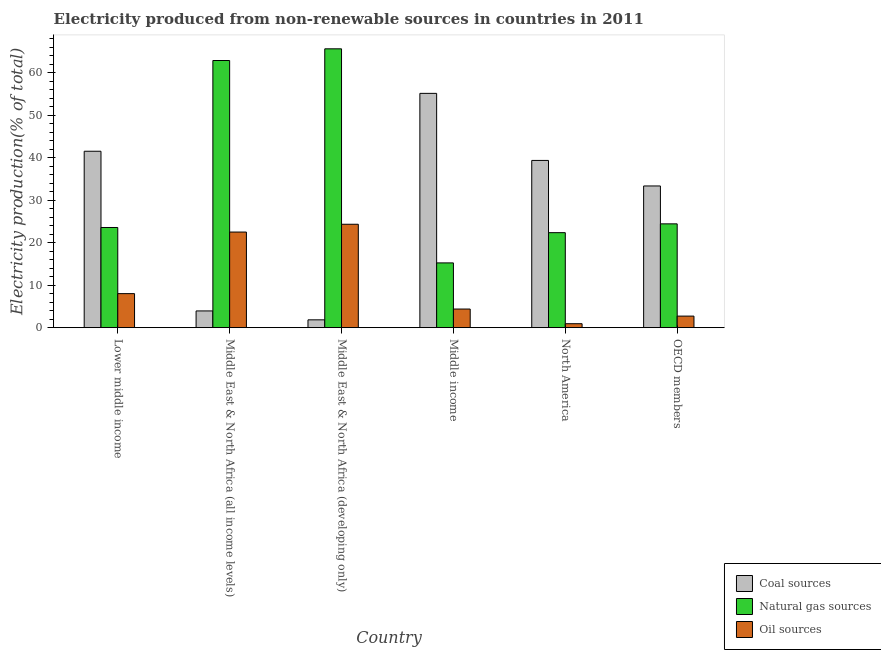What is the percentage of electricity produced by coal in Middle income?
Your answer should be very brief. 55.1. Across all countries, what is the maximum percentage of electricity produced by coal?
Your answer should be compact. 55.1. Across all countries, what is the minimum percentage of electricity produced by oil sources?
Ensure brevity in your answer.  0.93. In which country was the percentage of electricity produced by oil sources maximum?
Your answer should be compact. Middle East & North Africa (developing only). What is the total percentage of electricity produced by coal in the graph?
Ensure brevity in your answer.  175.02. What is the difference between the percentage of electricity produced by coal in Middle East & North Africa (developing only) and that in North America?
Your answer should be compact. -37.49. What is the difference between the percentage of electricity produced by natural gas in OECD members and the percentage of electricity produced by oil sources in Middle East & North Africa (all income levels)?
Your answer should be very brief. 1.93. What is the average percentage of electricity produced by natural gas per country?
Provide a short and direct response. 35.66. What is the difference between the percentage of electricity produced by oil sources and percentage of electricity produced by coal in Middle income?
Your answer should be compact. -50.72. In how many countries, is the percentage of electricity produced by oil sources greater than 60 %?
Your response must be concise. 0. What is the ratio of the percentage of electricity produced by coal in Middle East & North Africa (all income levels) to that in North America?
Your answer should be compact. 0.1. Is the percentage of electricity produced by oil sources in Lower middle income less than that in Middle East & North Africa (developing only)?
Ensure brevity in your answer.  Yes. Is the difference between the percentage of electricity produced by coal in Lower middle income and Middle income greater than the difference between the percentage of electricity produced by oil sources in Lower middle income and Middle income?
Your answer should be very brief. No. What is the difference between the highest and the second highest percentage of electricity produced by coal?
Your answer should be very brief. 13.61. What is the difference between the highest and the lowest percentage of electricity produced by natural gas?
Offer a very short reply. 50.35. In how many countries, is the percentage of electricity produced by oil sources greater than the average percentage of electricity produced by oil sources taken over all countries?
Your answer should be compact. 2. What does the 3rd bar from the left in Middle East & North Africa (all income levels) represents?
Offer a terse response. Oil sources. What does the 2nd bar from the right in North America represents?
Give a very brief answer. Natural gas sources. Is it the case that in every country, the sum of the percentage of electricity produced by coal and percentage of electricity produced by natural gas is greater than the percentage of electricity produced by oil sources?
Provide a succinct answer. Yes. How many bars are there?
Your response must be concise. 18. Are the values on the major ticks of Y-axis written in scientific E-notation?
Ensure brevity in your answer.  No. Does the graph contain grids?
Provide a succinct answer. No. How are the legend labels stacked?
Your answer should be very brief. Vertical. What is the title of the graph?
Provide a succinct answer. Electricity produced from non-renewable sources in countries in 2011. Does "Textiles and clothing" appear as one of the legend labels in the graph?
Provide a short and direct response. No. What is the label or title of the X-axis?
Ensure brevity in your answer.  Country. What is the Electricity production(% of total) in Coal sources in Lower middle income?
Provide a succinct answer. 41.49. What is the Electricity production(% of total) in Natural gas sources in Lower middle income?
Provide a succinct answer. 23.56. What is the Electricity production(% of total) in Oil sources in Lower middle income?
Provide a succinct answer. 8. What is the Electricity production(% of total) in Coal sources in Middle East & North Africa (all income levels)?
Your answer should be compact. 3.93. What is the Electricity production(% of total) in Natural gas sources in Middle East & North Africa (all income levels)?
Provide a short and direct response. 62.83. What is the Electricity production(% of total) of Oil sources in Middle East & North Africa (all income levels)?
Offer a terse response. 22.48. What is the Electricity production(% of total) in Coal sources in Middle East & North Africa (developing only)?
Ensure brevity in your answer.  1.84. What is the Electricity production(% of total) in Natural gas sources in Middle East & North Africa (developing only)?
Provide a succinct answer. 65.58. What is the Electricity production(% of total) of Oil sources in Middle East & North Africa (developing only)?
Offer a terse response. 24.32. What is the Electricity production(% of total) of Coal sources in Middle income?
Your answer should be very brief. 55.1. What is the Electricity production(% of total) of Natural gas sources in Middle income?
Keep it short and to the point. 15.23. What is the Electricity production(% of total) in Oil sources in Middle income?
Offer a terse response. 4.38. What is the Electricity production(% of total) of Coal sources in North America?
Offer a very short reply. 39.33. What is the Electricity production(% of total) of Natural gas sources in North America?
Keep it short and to the point. 22.34. What is the Electricity production(% of total) of Oil sources in North America?
Provide a short and direct response. 0.93. What is the Electricity production(% of total) in Coal sources in OECD members?
Keep it short and to the point. 33.32. What is the Electricity production(% of total) of Natural gas sources in OECD members?
Give a very brief answer. 24.42. What is the Electricity production(% of total) of Oil sources in OECD members?
Give a very brief answer. 2.72. Across all countries, what is the maximum Electricity production(% of total) in Coal sources?
Your response must be concise. 55.1. Across all countries, what is the maximum Electricity production(% of total) of Natural gas sources?
Ensure brevity in your answer.  65.58. Across all countries, what is the maximum Electricity production(% of total) in Oil sources?
Give a very brief answer. 24.32. Across all countries, what is the minimum Electricity production(% of total) in Coal sources?
Ensure brevity in your answer.  1.84. Across all countries, what is the minimum Electricity production(% of total) of Natural gas sources?
Provide a short and direct response. 15.23. Across all countries, what is the minimum Electricity production(% of total) of Oil sources?
Make the answer very short. 0.93. What is the total Electricity production(% of total) in Coal sources in the graph?
Offer a very short reply. 175.02. What is the total Electricity production(% of total) in Natural gas sources in the graph?
Your answer should be very brief. 213.96. What is the total Electricity production(% of total) in Oil sources in the graph?
Make the answer very short. 62.84. What is the difference between the Electricity production(% of total) of Coal sources in Lower middle income and that in Middle East & North Africa (all income levels)?
Offer a terse response. 37.55. What is the difference between the Electricity production(% of total) in Natural gas sources in Lower middle income and that in Middle East & North Africa (all income levels)?
Keep it short and to the point. -39.27. What is the difference between the Electricity production(% of total) of Oil sources in Lower middle income and that in Middle East & North Africa (all income levels)?
Ensure brevity in your answer.  -14.48. What is the difference between the Electricity production(% of total) of Coal sources in Lower middle income and that in Middle East & North Africa (developing only)?
Your response must be concise. 39.65. What is the difference between the Electricity production(% of total) of Natural gas sources in Lower middle income and that in Middle East & North Africa (developing only)?
Provide a short and direct response. -42.02. What is the difference between the Electricity production(% of total) of Oil sources in Lower middle income and that in Middle East & North Africa (developing only)?
Your response must be concise. -16.32. What is the difference between the Electricity production(% of total) of Coal sources in Lower middle income and that in Middle income?
Your response must be concise. -13.61. What is the difference between the Electricity production(% of total) in Natural gas sources in Lower middle income and that in Middle income?
Your response must be concise. 8.33. What is the difference between the Electricity production(% of total) of Oil sources in Lower middle income and that in Middle income?
Offer a terse response. 3.62. What is the difference between the Electricity production(% of total) in Coal sources in Lower middle income and that in North America?
Ensure brevity in your answer.  2.16. What is the difference between the Electricity production(% of total) of Natural gas sources in Lower middle income and that in North America?
Offer a terse response. 1.22. What is the difference between the Electricity production(% of total) of Oil sources in Lower middle income and that in North America?
Your answer should be compact. 7.07. What is the difference between the Electricity production(% of total) of Coal sources in Lower middle income and that in OECD members?
Offer a terse response. 8.16. What is the difference between the Electricity production(% of total) of Natural gas sources in Lower middle income and that in OECD members?
Your response must be concise. -0.86. What is the difference between the Electricity production(% of total) of Oil sources in Lower middle income and that in OECD members?
Offer a very short reply. 5.28. What is the difference between the Electricity production(% of total) in Coal sources in Middle East & North Africa (all income levels) and that in Middle East & North Africa (developing only)?
Offer a terse response. 2.09. What is the difference between the Electricity production(% of total) of Natural gas sources in Middle East & North Africa (all income levels) and that in Middle East & North Africa (developing only)?
Offer a terse response. -2.75. What is the difference between the Electricity production(% of total) in Oil sources in Middle East & North Africa (all income levels) and that in Middle East & North Africa (developing only)?
Provide a succinct answer. -1.84. What is the difference between the Electricity production(% of total) in Coal sources in Middle East & North Africa (all income levels) and that in Middle income?
Make the answer very short. -51.17. What is the difference between the Electricity production(% of total) in Natural gas sources in Middle East & North Africa (all income levels) and that in Middle income?
Offer a terse response. 47.6. What is the difference between the Electricity production(% of total) in Oil sources in Middle East & North Africa (all income levels) and that in Middle income?
Ensure brevity in your answer.  18.1. What is the difference between the Electricity production(% of total) in Coal sources in Middle East & North Africa (all income levels) and that in North America?
Make the answer very short. -35.4. What is the difference between the Electricity production(% of total) of Natural gas sources in Middle East & North Africa (all income levels) and that in North America?
Your answer should be compact. 40.49. What is the difference between the Electricity production(% of total) of Oil sources in Middle East & North Africa (all income levels) and that in North America?
Make the answer very short. 21.55. What is the difference between the Electricity production(% of total) of Coal sources in Middle East & North Africa (all income levels) and that in OECD members?
Keep it short and to the point. -29.39. What is the difference between the Electricity production(% of total) in Natural gas sources in Middle East & North Africa (all income levels) and that in OECD members?
Provide a short and direct response. 38.41. What is the difference between the Electricity production(% of total) of Oil sources in Middle East & North Africa (all income levels) and that in OECD members?
Keep it short and to the point. 19.76. What is the difference between the Electricity production(% of total) in Coal sources in Middle East & North Africa (developing only) and that in Middle income?
Make the answer very short. -53.26. What is the difference between the Electricity production(% of total) in Natural gas sources in Middle East & North Africa (developing only) and that in Middle income?
Provide a short and direct response. 50.35. What is the difference between the Electricity production(% of total) of Oil sources in Middle East & North Africa (developing only) and that in Middle income?
Ensure brevity in your answer.  19.94. What is the difference between the Electricity production(% of total) of Coal sources in Middle East & North Africa (developing only) and that in North America?
Offer a very short reply. -37.49. What is the difference between the Electricity production(% of total) in Natural gas sources in Middle East & North Africa (developing only) and that in North America?
Your answer should be compact. 43.24. What is the difference between the Electricity production(% of total) of Oil sources in Middle East & North Africa (developing only) and that in North America?
Offer a very short reply. 23.39. What is the difference between the Electricity production(% of total) in Coal sources in Middle East & North Africa (developing only) and that in OECD members?
Your response must be concise. -31.48. What is the difference between the Electricity production(% of total) in Natural gas sources in Middle East & North Africa (developing only) and that in OECD members?
Your response must be concise. 41.16. What is the difference between the Electricity production(% of total) in Oil sources in Middle East & North Africa (developing only) and that in OECD members?
Offer a terse response. 21.6. What is the difference between the Electricity production(% of total) of Coal sources in Middle income and that in North America?
Keep it short and to the point. 15.77. What is the difference between the Electricity production(% of total) in Natural gas sources in Middle income and that in North America?
Your response must be concise. -7.11. What is the difference between the Electricity production(% of total) of Oil sources in Middle income and that in North America?
Provide a succinct answer. 3.45. What is the difference between the Electricity production(% of total) of Coal sources in Middle income and that in OECD members?
Your answer should be very brief. 21.78. What is the difference between the Electricity production(% of total) in Natural gas sources in Middle income and that in OECD members?
Ensure brevity in your answer.  -9.19. What is the difference between the Electricity production(% of total) in Oil sources in Middle income and that in OECD members?
Your answer should be very brief. 1.66. What is the difference between the Electricity production(% of total) of Coal sources in North America and that in OECD members?
Keep it short and to the point. 6.01. What is the difference between the Electricity production(% of total) of Natural gas sources in North America and that in OECD members?
Offer a terse response. -2.07. What is the difference between the Electricity production(% of total) of Oil sources in North America and that in OECD members?
Your answer should be compact. -1.79. What is the difference between the Electricity production(% of total) in Coal sources in Lower middle income and the Electricity production(% of total) in Natural gas sources in Middle East & North Africa (all income levels)?
Make the answer very short. -21.34. What is the difference between the Electricity production(% of total) of Coal sources in Lower middle income and the Electricity production(% of total) of Oil sources in Middle East & North Africa (all income levels)?
Keep it short and to the point. 19.01. What is the difference between the Electricity production(% of total) of Natural gas sources in Lower middle income and the Electricity production(% of total) of Oil sources in Middle East & North Africa (all income levels)?
Ensure brevity in your answer.  1.07. What is the difference between the Electricity production(% of total) in Coal sources in Lower middle income and the Electricity production(% of total) in Natural gas sources in Middle East & North Africa (developing only)?
Make the answer very short. -24.09. What is the difference between the Electricity production(% of total) in Coal sources in Lower middle income and the Electricity production(% of total) in Oil sources in Middle East & North Africa (developing only)?
Your answer should be very brief. 17.17. What is the difference between the Electricity production(% of total) of Natural gas sources in Lower middle income and the Electricity production(% of total) of Oil sources in Middle East & North Africa (developing only)?
Offer a very short reply. -0.76. What is the difference between the Electricity production(% of total) in Coal sources in Lower middle income and the Electricity production(% of total) in Natural gas sources in Middle income?
Offer a very short reply. 26.26. What is the difference between the Electricity production(% of total) in Coal sources in Lower middle income and the Electricity production(% of total) in Oil sources in Middle income?
Offer a terse response. 37.11. What is the difference between the Electricity production(% of total) in Natural gas sources in Lower middle income and the Electricity production(% of total) in Oil sources in Middle income?
Provide a short and direct response. 19.18. What is the difference between the Electricity production(% of total) in Coal sources in Lower middle income and the Electricity production(% of total) in Natural gas sources in North America?
Offer a terse response. 19.15. What is the difference between the Electricity production(% of total) in Coal sources in Lower middle income and the Electricity production(% of total) in Oil sources in North America?
Keep it short and to the point. 40.56. What is the difference between the Electricity production(% of total) in Natural gas sources in Lower middle income and the Electricity production(% of total) in Oil sources in North America?
Your response must be concise. 22.63. What is the difference between the Electricity production(% of total) in Coal sources in Lower middle income and the Electricity production(% of total) in Natural gas sources in OECD members?
Provide a succinct answer. 17.07. What is the difference between the Electricity production(% of total) in Coal sources in Lower middle income and the Electricity production(% of total) in Oil sources in OECD members?
Provide a short and direct response. 38.77. What is the difference between the Electricity production(% of total) of Natural gas sources in Lower middle income and the Electricity production(% of total) of Oil sources in OECD members?
Ensure brevity in your answer.  20.84. What is the difference between the Electricity production(% of total) in Coal sources in Middle East & North Africa (all income levels) and the Electricity production(% of total) in Natural gas sources in Middle East & North Africa (developing only)?
Provide a succinct answer. -61.64. What is the difference between the Electricity production(% of total) in Coal sources in Middle East & North Africa (all income levels) and the Electricity production(% of total) in Oil sources in Middle East & North Africa (developing only)?
Make the answer very short. -20.38. What is the difference between the Electricity production(% of total) in Natural gas sources in Middle East & North Africa (all income levels) and the Electricity production(% of total) in Oil sources in Middle East & North Africa (developing only)?
Your answer should be compact. 38.51. What is the difference between the Electricity production(% of total) in Coal sources in Middle East & North Africa (all income levels) and the Electricity production(% of total) in Natural gas sources in Middle income?
Offer a very short reply. -11.3. What is the difference between the Electricity production(% of total) in Coal sources in Middle East & North Africa (all income levels) and the Electricity production(% of total) in Oil sources in Middle income?
Your answer should be compact. -0.45. What is the difference between the Electricity production(% of total) of Natural gas sources in Middle East & North Africa (all income levels) and the Electricity production(% of total) of Oil sources in Middle income?
Make the answer very short. 58.45. What is the difference between the Electricity production(% of total) of Coal sources in Middle East & North Africa (all income levels) and the Electricity production(% of total) of Natural gas sources in North America?
Your answer should be compact. -18.41. What is the difference between the Electricity production(% of total) of Coal sources in Middle East & North Africa (all income levels) and the Electricity production(% of total) of Oil sources in North America?
Your response must be concise. 3.01. What is the difference between the Electricity production(% of total) of Natural gas sources in Middle East & North Africa (all income levels) and the Electricity production(% of total) of Oil sources in North America?
Provide a succinct answer. 61.9. What is the difference between the Electricity production(% of total) in Coal sources in Middle East & North Africa (all income levels) and the Electricity production(% of total) in Natural gas sources in OECD members?
Ensure brevity in your answer.  -20.48. What is the difference between the Electricity production(% of total) of Coal sources in Middle East & North Africa (all income levels) and the Electricity production(% of total) of Oil sources in OECD members?
Offer a very short reply. 1.21. What is the difference between the Electricity production(% of total) in Natural gas sources in Middle East & North Africa (all income levels) and the Electricity production(% of total) in Oil sources in OECD members?
Provide a short and direct response. 60.11. What is the difference between the Electricity production(% of total) of Coal sources in Middle East & North Africa (developing only) and the Electricity production(% of total) of Natural gas sources in Middle income?
Provide a succinct answer. -13.39. What is the difference between the Electricity production(% of total) in Coal sources in Middle East & North Africa (developing only) and the Electricity production(% of total) in Oil sources in Middle income?
Offer a terse response. -2.54. What is the difference between the Electricity production(% of total) in Natural gas sources in Middle East & North Africa (developing only) and the Electricity production(% of total) in Oil sources in Middle income?
Make the answer very short. 61.2. What is the difference between the Electricity production(% of total) of Coal sources in Middle East & North Africa (developing only) and the Electricity production(% of total) of Natural gas sources in North America?
Offer a very short reply. -20.5. What is the difference between the Electricity production(% of total) of Coal sources in Middle East & North Africa (developing only) and the Electricity production(% of total) of Oil sources in North America?
Keep it short and to the point. 0.91. What is the difference between the Electricity production(% of total) of Natural gas sources in Middle East & North Africa (developing only) and the Electricity production(% of total) of Oil sources in North America?
Provide a short and direct response. 64.65. What is the difference between the Electricity production(% of total) of Coal sources in Middle East & North Africa (developing only) and the Electricity production(% of total) of Natural gas sources in OECD members?
Your answer should be compact. -22.57. What is the difference between the Electricity production(% of total) of Coal sources in Middle East & North Africa (developing only) and the Electricity production(% of total) of Oil sources in OECD members?
Make the answer very short. -0.88. What is the difference between the Electricity production(% of total) of Natural gas sources in Middle East & North Africa (developing only) and the Electricity production(% of total) of Oil sources in OECD members?
Your answer should be very brief. 62.86. What is the difference between the Electricity production(% of total) in Coal sources in Middle income and the Electricity production(% of total) in Natural gas sources in North America?
Give a very brief answer. 32.76. What is the difference between the Electricity production(% of total) in Coal sources in Middle income and the Electricity production(% of total) in Oil sources in North America?
Your answer should be very brief. 54.17. What is the difference between the Electricity production(% of total) of Natural gas sources in Middle income and the Electricity production(% of total) of Oil sources in North America?
Your answer should be very brief. 14.3. What is the difference between the Electricity production(% of total) of Coal sources in Middle income and the Electricity production(% of total) of Natural gas sources in OECD members?
Offer a very short reply. 30.69. What is the difference between the Electricity production(% of total) in Coal sources in Middle income and the Electricity production(% of total) in Oil sources in OECD members?
Keep it short and to the point. 52.38. What is the difference between the Electricity production(% of total) in Natural gas sources in Middle income and the Electricity production(% of total) in Oil sources in OECD members?
Your answer should be compact. 12.51. What is the difference between the Electricity production(% of total) in Coal sources in North America and the Electricity production(% of total) in Natural gas sources in OECD members?
Provide a succinct answer. 14.92. What is the difference between the Electricity production(% of total) of Coal sources in North America and the Electricity production(% of total) of Oil sources in OECD members?
Your answer should be very brief. 36.61. What is the difference between the Electricity production(% of total) of Natural gas sources in North America and the Electricity production(% of total) of Oil sources in OECD members?
Ensure brevity in your answer.  19.62. What is the average Electricity production(% of total) of Coal sources per country?
Ensure brevity in your answer.  29.17. What is the average Electricity production(% of total) of Natural gas sources per country?
Give a very brief answer. 35.66. What is the average Electricity production(% of total) of Oil sources per country?
Provide a succinct answer. 10.47. What is the difference between the Electricity production(% of total) in Coal sources and Electricity production(% of total) in Natural gas sources in Lower middle income?
Give a very brief answer. 17.93. What is the difference between the Electricity production(% of total) of Coal sources and Electricity production(% of total) of Oil sources in Lower middle income?
Ensure brevity in your answer.  33.49. What is the difference between the Electricity production(% of total) in Natural gas sources and Electricity production(% of total) in Oil sources in Lower middle income?
Your response must be concise. 15.56. What is the difference between the Electricity production(% of total) in Coal sources and Electricity production(% of total) in Natural gas sources in Middle East & North Africa (all income levels)?
Ensure brevity in your answer.  -58.89. What is the difference between the Electricity production(% of total) in Coal sources and Electricity production(% of total) in Oil sources in Middle East & North Africa (all income levels)?
Give a very brief answer. -18.55. What is the difference between the Electricity production(% of total) in Natural gas sources and Electricity production(% of total) in Oil sources in Middle East & North Africa (all income levels)?
Give a very brief answer. 40.34. What is the difference between the Electricity production(% of total) of Coal sources and Electricity production(% of total) of Natural gas sources in Middle East & North Africa (developing only)?
Your answer should be very brief. -63.74. What is the difference between the Electricity production(% of total) of Coal sources and Electricity production(% of total) of Oil sources in Middle East & North Africa (developing only)?
Ensure brevity in your answer.  -22.48. What is the difference between the Electricity production(% of total) of Natural gas sources and Electricity production(% of total) of Oil sources in Middle East & North Africa (developing only)?
Keep it short and to the point. 41.26. What is the difference between the Electricity production(% of total) in Coal sources and Electricity production(% of total) in Natural gas sources in Middle income?
Give a very brief answer. 39.87. What is the difference between the Electricity production(% of total) in Coal sources and Electricity production(% of total) in Oil sources in Middle income?
Ensure brevity in your answer.  50.72. What is the difference between the Electricity production(% of total) in Natural gas sources and Electricity production(% of total) in Oil sources in Middle income?
Provide a short and direct response. 10.85. What is the difference between the Electricity production(% of total) in Coal sources and Electricity production(% of total) in Natural gas sources in North America?
Make the answer very short. 16.99. What is the difference between the Electricity production(% of total) of Coal sources and Electricity production(% of total) of Oil sources in North America?
Offer a very short reply. 38.4. What is the difference between the Electricity production(% of total) in Natural gas sources and Electricity production(% of total) in Oil sources in North America?
Ensure brevity in your answer.  21.41. What is the difference between the Electricity production(% of total) of Coal sources and Electricity production(% of total) of Natural gas sources in OECD members?
Make the answer very short. 8.91. What is the difference between the Electricity production(% of total) in Coal sources and Electricity production(% of total) in Oil sources in OECD members?
Your response must be concise. 30.6. What is the difference between the Electricity production(% of total) of Natural gas sources and Electricity production(% of total) of Oil sources in OECD members?
Your answer should be very brief. 21.7. What is the ratio of the Electricity production(% of total) of Coal sources in Lower middle income to that in Middle East & North Africa (all income levels)?
Keep it short and to the point. 10.54. What is the ratio of the Electricity production(% of total) of Oil sources in Lower middle income to that in Middle East & North Africa (all income levels)?
Your answer should be very brief. 0.36. What is the ratio of the Electricity production(% of total) in Coal sources in Lower middle income to that in Middle East & North Africa (developing only)?
Offer a terse response. 22.52. What is the ratio of the Electricity production(% of total) in Natural gas sources in Lower middle income to that in Middle East & North Africa (developing only)?
Give a very brief answer. 0.36. What is the ratio of the Electricity production(% of total) in Oil sources in Lower middle income to that in Middle East & North Africa (developing only)?
Your answer should be compact. 0.33. What is the ratio of the Electricity production(% of total) in Coal sources in Lower middle income to that in Middle income?
Ensure brevity in your answer.  0.75. What is the ratio of the Electricity production(% of total) of Natural gas sources in Lower middle income to that in Middle income?
Make the answer very short. 1.55. What is the ratio of the Electricity production(% of total) of Oil sources in Lower middle income to that in Middle income?
Make the answer very short. 1.83. What is the ratio of the Electricity production(% of total) of Coal sources in Lower middle income to that in North America?
Give a very brief answer. 1.05. What is the ratio of the Electricity production(% of total) of Natural gas sources in Lower middle income to that in North America?
Your response must be concise. 1.05. What is the ratio of the Electricity production(% of total) of Oil sources in Lower middle income to that in North America?
Your answer should be compact. 8.61. What is the ratio of the Electricity production(% of total) in Coal sources in Lower middle income to that in OECD members?
Your answer should be very brief. 1.25. What is the ratio of the Electricity production(% of total) in Natural gas sources in Lower middle income to that in OECD members?
Keep it short and to the point. 0.96. What is the ratio of the Electricity production(% of total) of Oil sources in Lower middle income to that in OECD members?
Your answer should be very brief. 2.94. What is the ratio of the Electricity production(% of total) in Coal sources in Middle East & North Africa (all income levels) to that in Middle East & North Africa (developing only)?
Provide a succinct answer. 2.14. What is the ratio of the Electricity production(% of total) in Natural gas sources in Middle East & North Africa (all income levels) to that in Middle East & North Africa (developing only)?
Provide a succinct answer. 0.96. What is the ratio of the Electricity production(% of total) in Oil sources in Middle East & North Africa (all income levels) to that in Middle East & North Africa (developing only)?
Your answer should be compact. 0.92. What is the ratio of the Electricity production(% of total) in Coal sources in Middle East & North Africa (all income levels) to that in Middle income?
Provide a short and direct response. 0.07. What is the ratio of the Electricity production(% of total) in Natural gas sources in Middle East & North Africa (all income levels) to that in Middle income?
Provide a short and direct response. 4.13. What is the ratio of the Electricity production(% of total) of Oil sources in Middle East & North Africa (all income levels) to that in Middle income?
Provide a succinct answer. 5.13. What is the ratio of the Electricity production(% of total) of Coal sources in Middle East & North Africa (all income levels) to that in North America?
Provide a short and direct response. 0.1. What is the ratio of the Electricity production(% of total) in Natural gas sources in Middle East & North Africa (all income levels) to that in North America?
Offer a terse response. 2.81. What is the ratio of the Electricity production(% of total) in Oil sources in Middle East & North Africa (all income levels) to that in North America?
Your response must be concise. 24.19. What is the ratio of the Electricity production(% of total) in Coal sources in Middle East & North Africa (all income levels) to that in OECD members?
Make the answer very short. 0.12. What is the ratio of the Electricity production(% of total) of Natural gas sources in Middle East & North Africa (all income levels) to that in OECD members?
Your answer should be very brief. 2.57. What is the ratio of the Electricity production(% of total) of Oil sources in Middle East & North Africa (all income levels) to that in OECD members?
Your answer should be very brief. 8.27. What is the ratio of the Electricity production(% of total) in Coal sources in Middle East & North Africa (developing only) to that in Middle income?
Your response must be concise. 0.03. What is the ratio of the Electricity production(% of total) in Natural gas sources in Middle East & North Africa (developing only) to that in Middle income?
Make the answer very short. 4.31. What is the ratio of the Electricity production(% of total) of Oil sources in Middle East & North Africa (developing only) to that in Middle income?
Give a very brief answer. 5.55. What is the ratio of the Electricity production(% of total) in Coal sources in Middle East & North Africa (developing only) to that in North America?
Your answer should be compact. 0.05. What is the ratio of the Electricity production(% of total) in Natural gas sources in Middle East & North Africa (developing only) to that in North America?
Provide a succinct answer. 2.94. What is the ratio of the Electricity production(% of total) of Oil sources in Middle East & North Africa (developing only) to that in North America?
Ensure brevity in your answer.  26.17. What is the ratio of the Electricity production(% of total) of Coal sources in Middle East & North Africa (developing only) to that in OECD members?
Give a very brief answer. 0.06. What is the ratio of the Electricity production(% of total) in Natural gas sources in Middle East & North Africa (developing only) to that in OECD members?
Offer a very short reply. 2.69. What is the ratio of the Electricity production(% of total) of Oil sources in Middle East & North Africa (developing only) to that in OECD members?
Make the answer very short. 8.94. What is the ratio of the Electricity production(% of total) of Coal sources in Middle income to that in North America?
Provide a succinct answer. 1.4. What is the ratio of the Electricity production(% of total) of Natural gas sources in Middle income to that in North America?
Your answer should be compact. 0.68. What is the ratio of the Electricity production(% of total) of Oil sources in Middle income to that in North America?
Your answer should be very brief. 4.71. What is the ratio of the Electricity production(% of total) of Coal sources in Middle income to that in OECD members?
Your answer should be compact. 1.65. What is the ratio of the Electricity production(% of total) in Natural gas sources in Middle income to that in OECD members?
Offer a very short reply. 0.62. What is the ratio of the Electricity production(% of total) in Oil sources in Middle income to that in OECD members?
Your answer should be very brief. 1.61. What is the ratio of the Electricity production(% of total) of Coal sources in North America to that in OECD members?
Give a very brief answer. 1.18. What is the ratio of the Electricity production(% of total) of Natural gas sources in North America to that in OECD members?
Your answer should be compact. 0.92. What is the ratio of the Electricity production(% of total) of Oil sources in North America to that in OECD members?
Offer a terse response. 0.34. What is the difference between the highest and the second highest Electricity production(% of total) of Coal sources?
Give a very brief answer. 13.61. What is the difference between the highest and the second highest Electricity production(% of total) of Natural gas sources?
Make the answer very short. 2.75. What is the difference between the highest and the second highest Electricity production(% of total) of Oil sources?
Your response must be concise. 1.84. What is the difference between the highest and the lowest Electricity production(% of total) in Coal sources?
Your response must be concise. 53.26. What is the difference between the highest and the lowest Electricity production(% of total) in Natural gas sources?
Provide a short and direct response. 50.35. What is the difference between the highest and the lowest Electricity production(% of total) of Oil sources?
Provide a succinct answer. 23.39. 